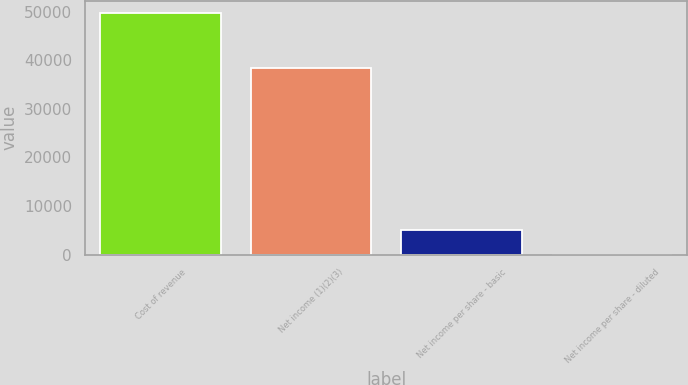Convert chart. <chart><loc_0><loc_0><loc_500><loc_500><bar_chart><fcel>Cost of revenue<fcel>Net income (1)(2)(3)<fcel>Net income per share - basic<fcel>Net income per share - diluted<nl><fcel>49736<fcel>38500<fcel>4973.72<fcel>0.13<nl></chart> 